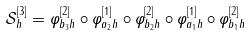<formula> <loc_0><loc_0><loc_500><loc_500>\mathcal { S } _ { h } ^ { [ 3 ] } = \varphi _ { b _ { 3 } h } ^ { [ 2 ] } \circ \varphi _ { a _ { 2 } h } ^ { [ 1 ] } \circ \varphi _ { b _ { 2 } h } ^ { [ 2 ] } \circ \varphi _ { a _ { 1 } h } ^ { [ 1 ] } \circ \varphi _ { b _ { 1 } h } ^ { [ 2 ] }</formula> 